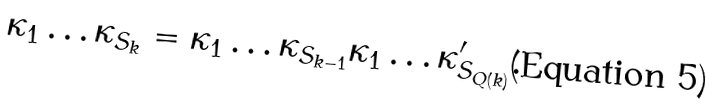<formula> <loc_0><loc_0><loc_500><loc_500>\kappa _ { 1 } \dots \kappa _ { S _ { k } } = \kappa _ { 1 } \dots \kappa _ { S _ { k - 1 } } \kappa _ { 1 } \dots \kappa ^ { \prime } _ { S _ { Q ( k ) } } .</formula> 